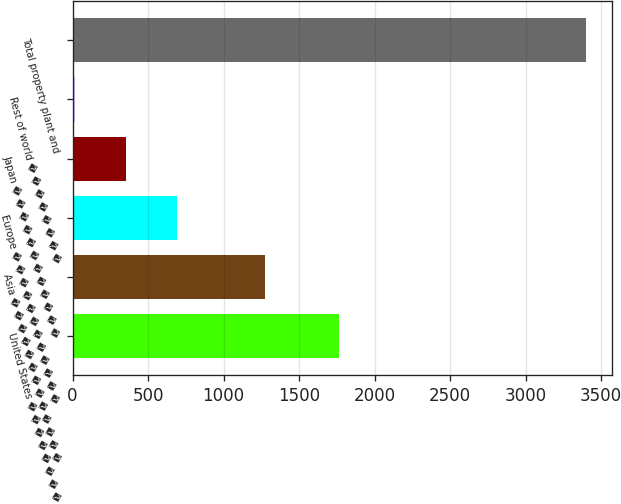Convert chart to OTSL. <chart><loc_0><loc_0><loc_500><loc_500><bar_chart><fcel>United States � � � � � � � �<fcel>Asia � � � � � � � � � � � � �<fcel>Europe � � � � � � � � � � � �<fcel>Japan � � � � � � � � � � � �<fcel>Rest of world � � � � � � � �<fcel>Total property plant and<nl><fcel>1765<fcel>1277<fcel>693.4<fcel>355.2<fcel>17<fcel>3399<nl></chart> 